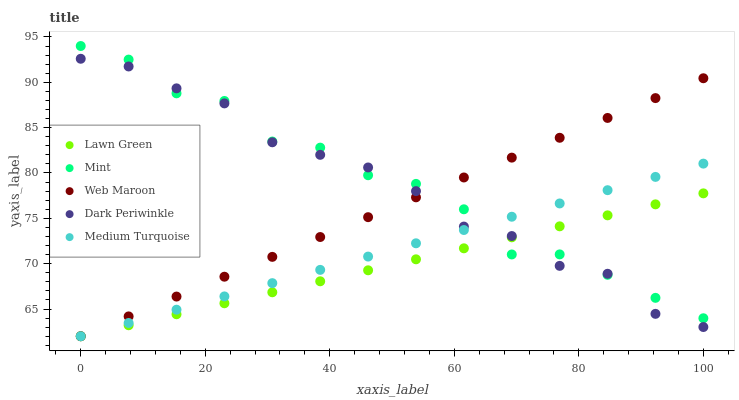Does Lawn Green have the minimum area under the curve?
Answer yes or no. Yes. Does Mint have the maximum area under the curve?
Answer yes or no. Yes. Does Medium Turquoise have the minimum area under the curve?
Answer yes or no. No. Does Medium Turquoise have the maximum area under the curve?
Answer yes or no. No. Is Medium Turquoise the smoothest?
Answer yes or no. Yes. Is Mint the roughest?
Answer yes or no. Yes. Is Mint the smoothest?
Answer yes or no. No. Is Medium Turquoise the roughest?
Answer yes or no. No. Does Lawn Green have the lowest value?
Answer yes or no. Yes. Does Mint have the lowest value?
Answer yes or no. No. Does Mint have the highest value?
Answer yes or no. Yes. Does Medium Turquoise have the highest value?
Answer yes or no. No. Does Dark Periwinkle intersect Medium Turquoise?
Answer yes or no. Yes. Is Dark Periwinkle less than Medium Turquoise?
Answer yes or no. No. Is Dark Periwinkle greater than Medium Turquoise?
Answer yes or no. No. 